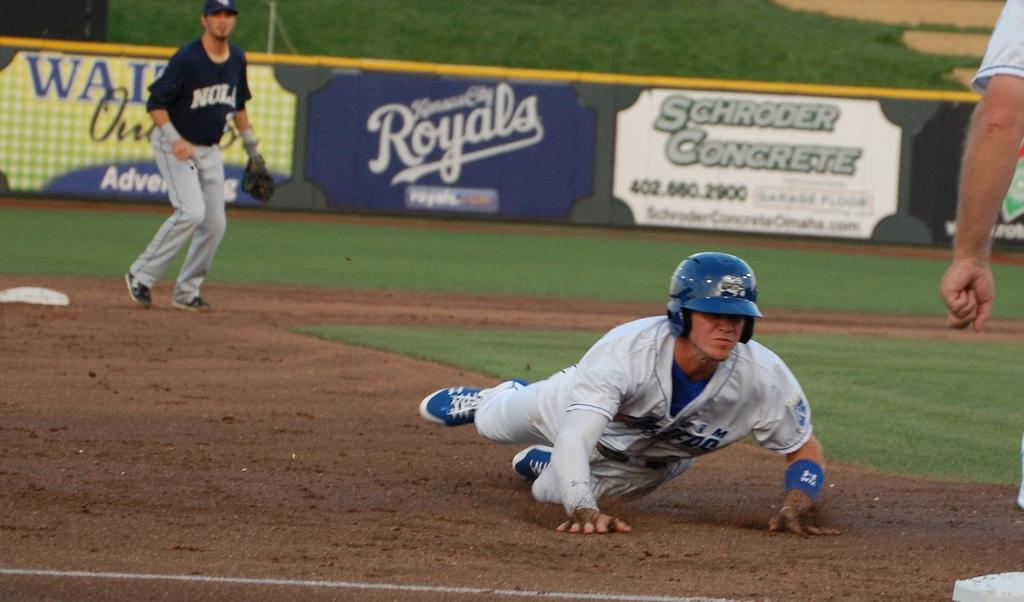What is happening on the ground in the image? There are people on the ground in the image. What can be seen in the background of the image? There is an advertisement board and grass visible in the background of the image. What type of button can be seen in the image? There is no button present in the image. How quiet is the scene in the image? The provided facts do not give any information about the noise level in the image, so it cannot be determined from the image. 